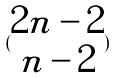<formula> <loc_0><loc_0><loc_500><loc_500>( \begin{matrix} 2 n - 2 \\ n - 2 \end{matrix} )</formula> 